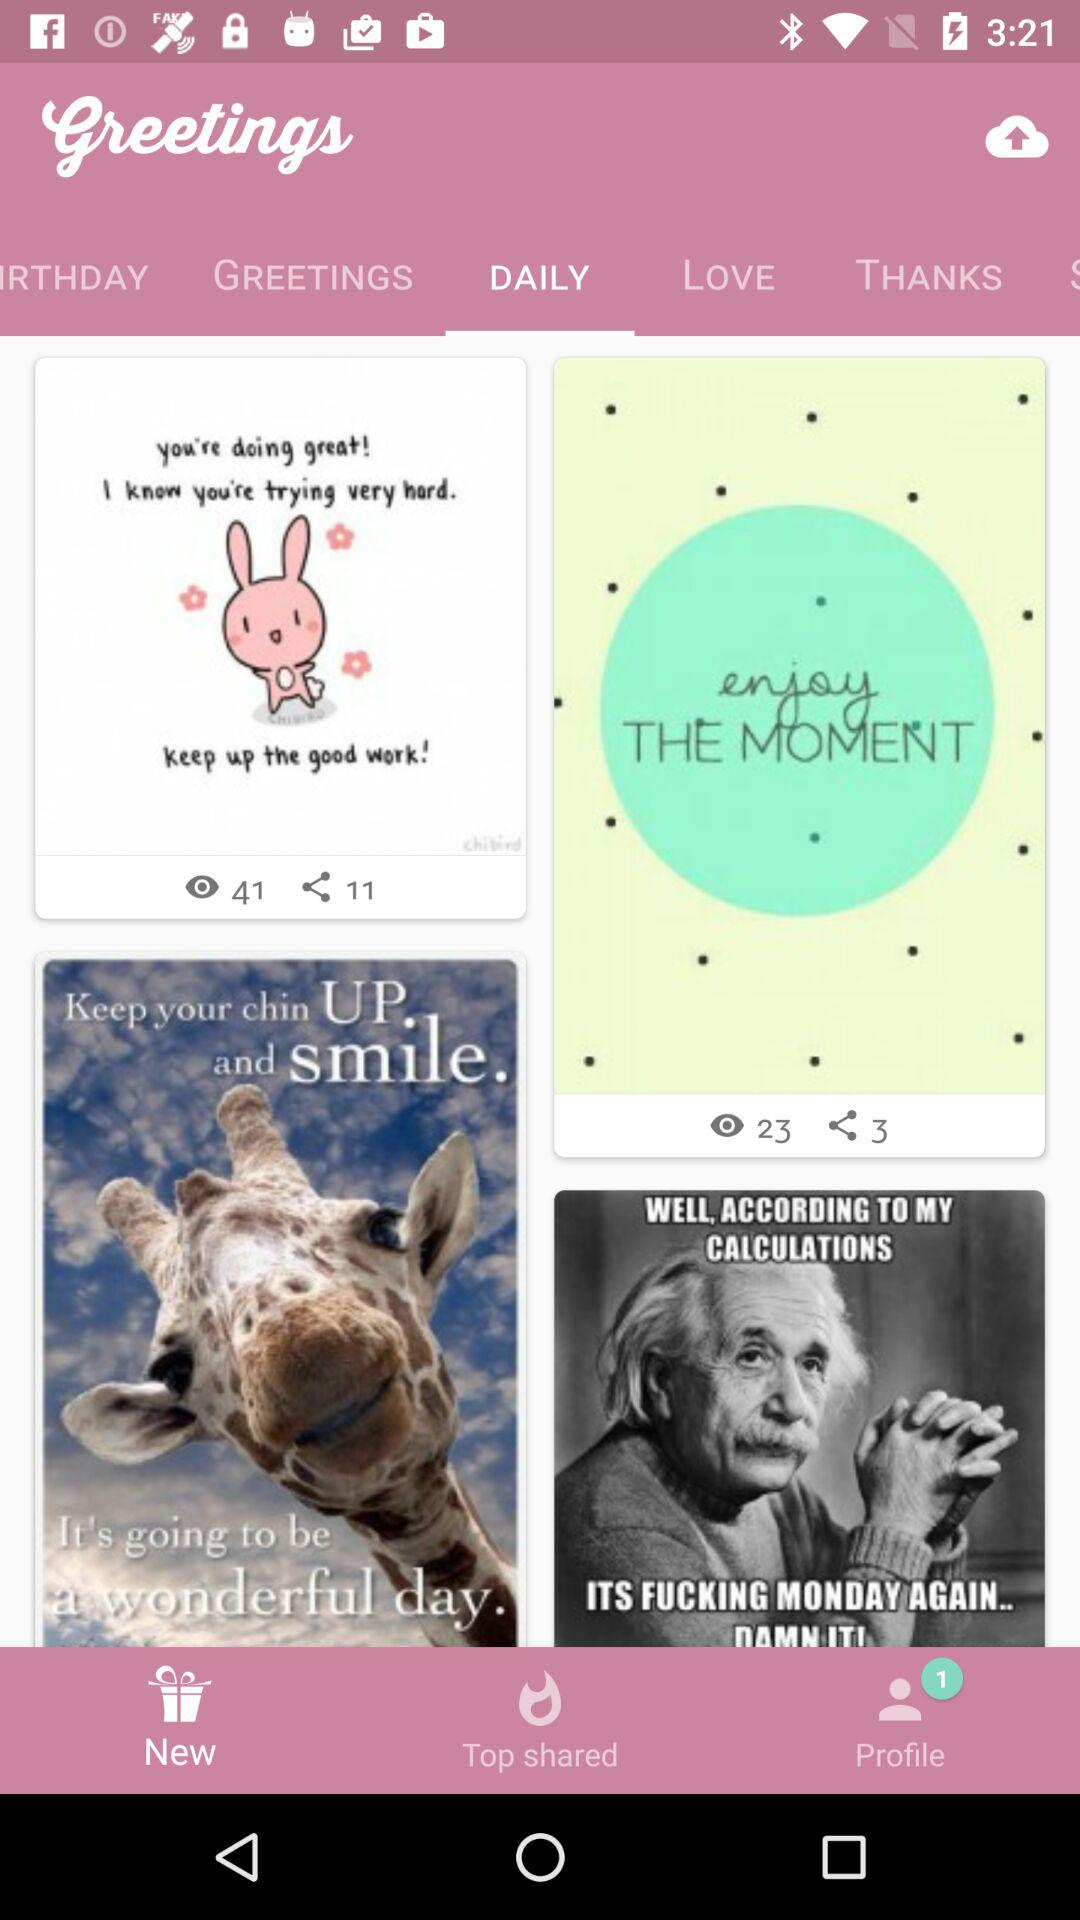How many views are there of the "enjoy THE MOMENT" greeting? There are 23 views of the "enjoy THE MOMENT" greeting. 